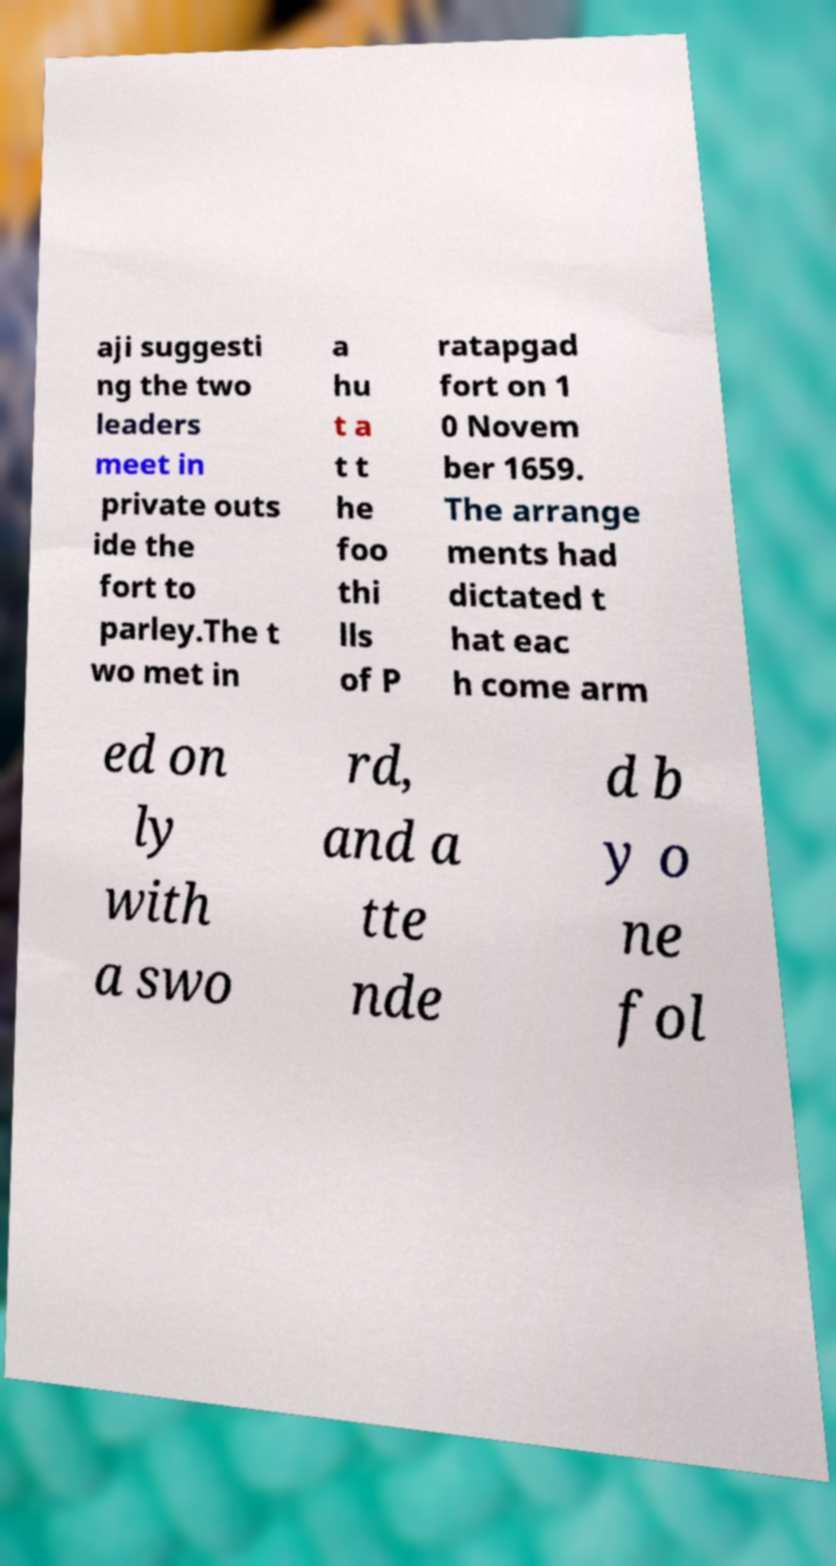Could you assist in decoding the text presented in this image and type it out clearly? aji suggesti ng the two leaders meet in private outs ide the fort to parley.The t wo met in a hu t a t t he foo thi lls of P ratapgad fort on 1 0 Novem ber 1659. The arrange ments had dictated t hat eac h come arm ed on ly with a swo rd, and a tte nde d b y o ne fol 